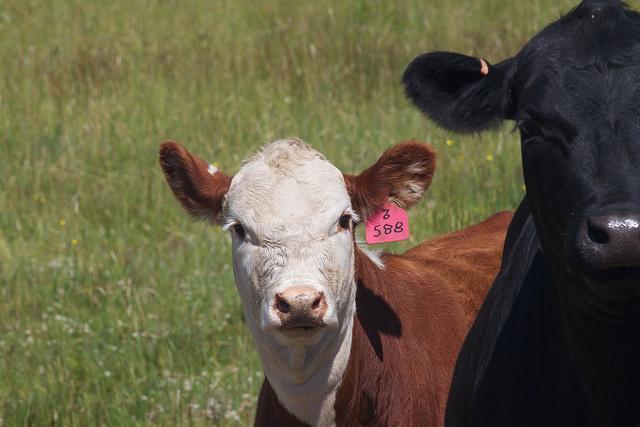How many cows are there?
Give a very brief answer. 2. 